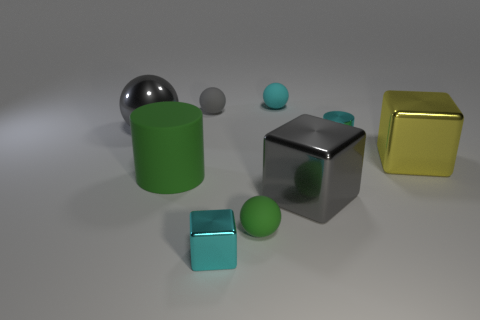Subtract all purple spheres. Subtract all red cylinders. How many spheres are left? 4 Add 1 large purple metal cubes. How many objects exist? 10 Subtract all spheres. How many objects are left? 5 Subtract 1 cyan balls. How many objects are left? 8 Subtract all cyan blocks. Subtract all big green rubber cylinders. How many objects are left? 7 Add 7 tiny green objects. How many tiny green objects are left? 8 Add 6 tiny spheres. How many tiny spheres exist? 9 